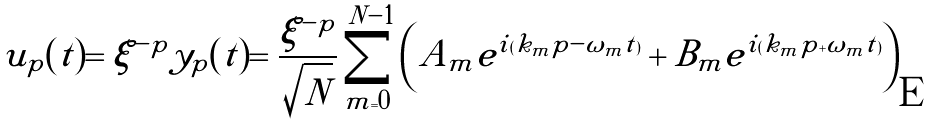Convert formula to latex. <formula><loc_0><loc_0><loc_500><loc_500>u _ { p } ( t ) = \xi ^ { - p } y _ { p } ( t ) = \frac { \xi ^ { - p } } { \sqrt { N } } \sum _ { m = 0 } ^ { N - 1 } \left ( A _ { m } e ^ { i ( k _ { m } p - \omega _ { m } t ) } + B _ { m } e ^ { i ( k _ { m } p + \omega _ { m } t ) } \right )</formula> 